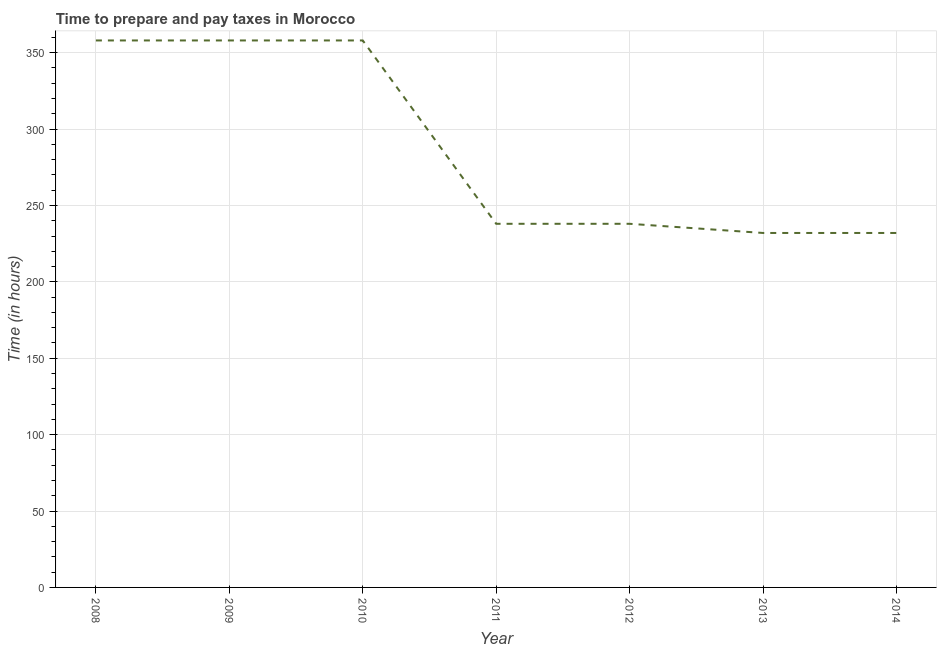What is the time to prepare and pay taxes in 2010?
Ensure brevity in your answer.  358. Across all years, what is the maximum time to prepare and pay taxes?
Keep it short and to the point. 358. Across all years, what is the minimum time to prepare and pay taxes?
Ensure brevity in your answer.  232. What is the sum of the time to prepare and pay taxes?
Offer a terse response. 2014. What is the difference between the time to prepare and pay taxes in 2010 and 2014?
Give a very brief answer. 126. What is the average time to prepare and pay taxes per year?
Give a very brief answer. 287.71. What is the median time to prepare and pay taxes?
Provide a short and direct response. 238. In how many years, is the time to prepare and pay taxes greater than 110 hours?
Offer a very short reply. 7. What is the ratio of the time to prepare and pay taxes in 2009 to that in 2014?
Make the answer very short. 1.54. Is the time to prepare and pay taxes in 2008 less than that in 2010?
Provide a succinct answer. No. What is the difference between the highest and the second highest time to prepare and pay taxes?
Keep it short and to the point. 0. Is the sum of the time to prepare and pay taxes in 2011 and 2013 greater than the maximum time to prepare and pay taxes across all years?
Offer a very short reply. Yes. What is the difference between the highest and the lowest time to prepare and pay taxes?
Offer a terse response. 126. Does the time to prepare and pay taxes monotonically increase over the years?
Provide a succinct answer. No. How many lines are there?
Provide a succinct answer. 1. Are the values on the major ticks of Y-axis written in scientific E-notation?
Make the answer very short. No. What is the title of the graph?
Provide a short and direct response. Time to prepare and pay taxes in Morocco. What is the label or title of the X-axis?
Provide a succinct answer. Year. What is the label or title of the Y-axis?
Provide a short and direct response. Time (in hours). What is the Time (in hours) in 2008?
Make the answer very short. 358. What is the Time (in hours) of 2009?
Your answer should be very brief. 358. What is the Time (in hours) of 2010?
Provide a short and direct response. 358. What is the Time (in hours) in 2011?
Offer a very short reply. 238. What is the Time (in hours) in 2012?
Provide a short and direct response. 238. What is the Time (in hours) of 2013?
Your answer should be compact. 232. What is the Time (in hours) in 2014?
Your answer should be compact. 232. What is the difference between the Time (in hours) in 2008 and 2010?
Offer a terse response. 0. What is the difference between the Time (in hours) in 2008 and 2011?
Your response must be concise. 120. What is the difference between the Time (in hours) in 2008 and 2012?
Ensure brevity in your answer.  120. What is the difference between the Time (in hours) in 2008 and 2013?
Your answer should be compact. 126. What is the difference between the Time (in hours) in 2008 and 2014?
Your answer should be compact. 126. What is the difference between the Time (in hours) in 2009 and 2010?
Make the answer very short. 0. What is the difference between the Time (in hours) in 2009 and 2011?
Your answer should be compact. 120. What is the difference between the Time (in hours) in 2009 and 2012?
Give a very brief answer. 120. What is the difference between the Time (in hours) in 2009 and 2013?
Make the answer very short. 126. What is the difference between the Time (in hours) in 2009 and 2014?
Give a very brief answer. 126. What is the difference between the Time (in hours) in 2010 and 2011?
Offer a very short reply. 120. What is the difference between the Time (in hours) in 2010 and 2012?
Offer a very short reply. 120. What is the difference between the Time (in hours) in 2010 and 2013?
Your response must be concise. 126. What is the difference between the Time (in hours) in 2010 and 2014?
Provide a short and direct response. 126. What is the difference between the Time (in hours) in 2012 and 2014?
Keep it short and to the point. 6. What is the difference between the Time (in hours) in 2013 and 2014?
Offer a terse response. 0. What is the ratio of the Time (in hours) in 2008 to that in 2009?
Make the answer very short. 1. What is the ratio of the Time (in hours) in 2008 to that in 2011?
Make the answer very short. 1.5. What is the ratio of the Time (in hours) in 2008 to that in 2012?
Your response must be concise. 1.5. What is the ratio of the Time (in hours) in 2008 to that in 2013?
Your answer should be very brief. 1.54. What is the ratio of the Time (in hours) in 2008 to that in 2014?
Keep it short and to the point. 1.54. What is the ratio of the Time (in hours) in 2009 to that in 2010?
Your answer should be compact. 1. What is the ratio of the Time (in hours) in 2009 to that in 2011?
Make the answer very short. 1.5. What is the ratio of the Time (in hours) in 2009 to that in 2012?
Make the answer very short. 1.5. What is the ratio of the Time (in hours) in 2009 to that in 2013?
Provide a succinct answer. 1.54. What is the ratio of the Time (in hours) in 2009 to that in 2014?
Make the answer very short. 1.54. What is the ratio of the Time (in hours) in 2010 to that in 2011?
Your answer should be very brief. 1.5. What is the ratio of the Time (in hours) in 2010 to that in 2012?
Keep it short and to the point. 1.5. What is the ratio of the Time (in hours) in 2010 to that in 2013?
Keep it short and to the point. 1.54. What is the ratio of the Time (in hours) in 2010 to that in 2014?
Ensure brevity in your answer.  1.54. What is the ratio of the Time (in hours) in 2012 to that in 2014?
Provide a succinct answer. 1.03. What is the ratio of the Time (in hours) in 2013 to that in 2014?
Your answer should be very brief. 1. 